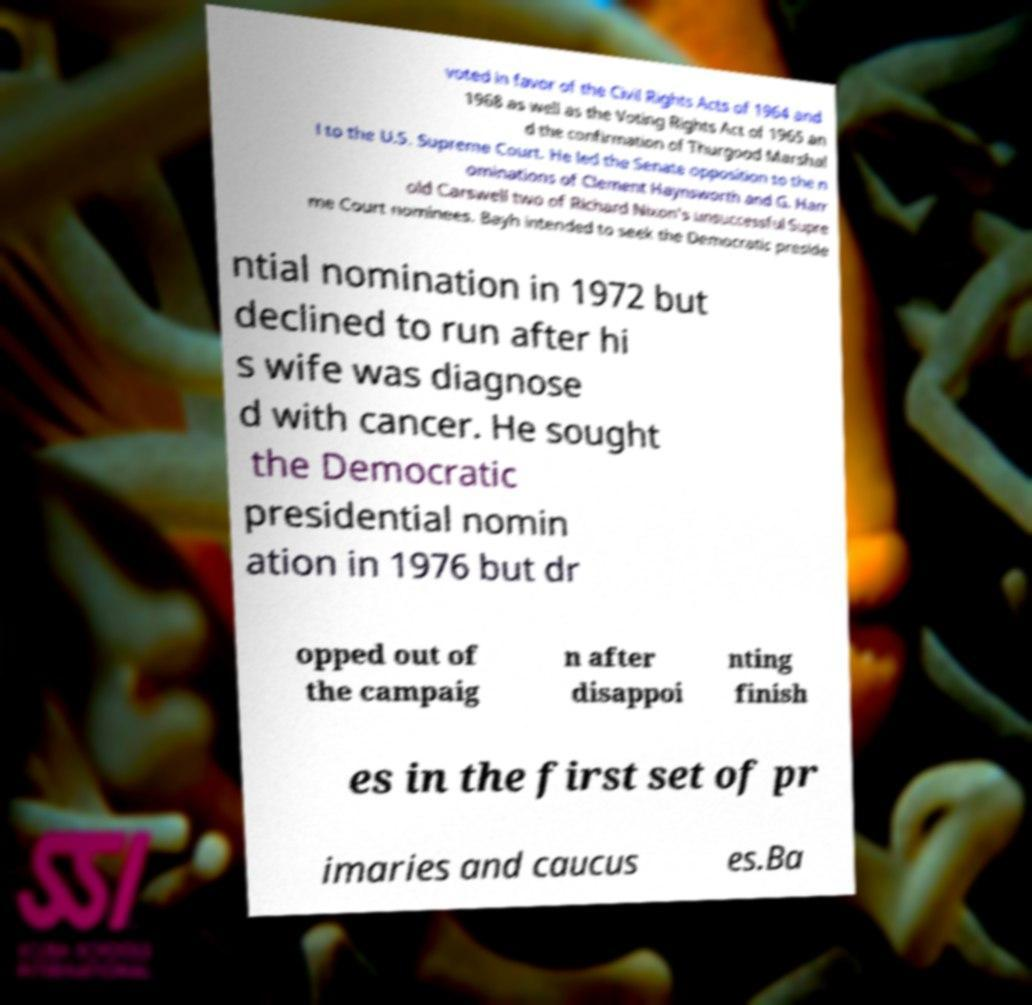Could you extract and type out the text from this image? voted in favor of the Civil Rights Acts of 1964 and 1968 as well as the Voting Rights Act of 1965 an d the confirmation of Thurgood Marshal l to the U.S. Supreme Court. He led the Senate opposition to the n ominations of Clement Haynsworth and G. Harr old Carswell two of Richard Nixon's unsuccessful Supre me Court nominees. Bayh intended to seek the Democratic preside ntial nomination in 1972 but declined to run after hi s wife was diagnose d with cancer. He sought the Democratic presidential nomin ation in 1976 but dr opped out of the campaig n after disappoi nting finish es in the first set of pr imaries and caucus es.Ba 